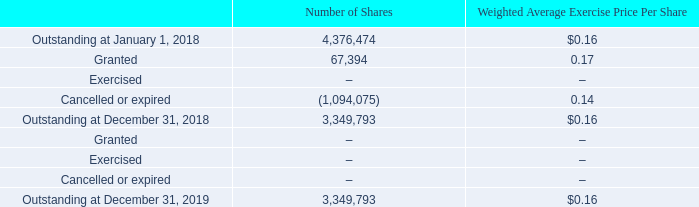Transactions involving stock options issued to employees are summarized as follows:
The expected life of awards granted represents the period of time that they are expected to be outstanding. The Company determines the expected life based on historical experience with similar awards, giving consideration to the contractual terms, vesting schedules, exercise patterns and pre-vesting and post-vesting forfeitures. The Company estimates the volatility of the Company’s common stock based on the calculated historical volatility of the Company’s common stock using the share price data for the trailing period equal to the expected term prior to the date of the award. The Company bases the risk-free interest rate used in the Black-Scholes option valuation model on the implied yield currently available on U.S. Treasury zero-coupon issues with an equivalent remaining term equal to the expected life of the award. The Company has not paid any cash dividends on the Company’s common stock and does not anticipate paying any cash dividends in the foreseeable future. Consequently, the Company uses an expected dividend yield of zero in the Black-Scholes option valuation model. The Company uses historical data to estimate pre-vesting option forfeitures and records share-based compensation for those awards that are expected to vest. In accordance with ASC 718-10, the Company calculates share-based compensation for changes to the estimate of expected equity award forfeitures based on actual forfeiture experience.
What does the expected life of awards granted represent? The period of time that they are expected to be outstanding. How is the volatility of the Company's common stock estimated? Based on the calculated historical volatility of the company’s common stock using the share price data for the trailing period equal to the expected term prior to the date of the award. What is the valuation model used by the Company? The black-scholes option valuation model. What is the percentage change in the outstanding number of shares from January 1, 2018 to December 31, 2018?
Answer scale should be: percent. (3,349,793-4,376,474)/4,376,474
Answer: -23.46. Which stock option has the highest weighted average exercise price per share in 2018? Find the highest weighted average exercise price per share in 2018
answer: granted. What is the change in the outstanding number of shares from December 31, 2018 to December 31, 2019? 3,349,793-3,349,793
Answer: 0. 